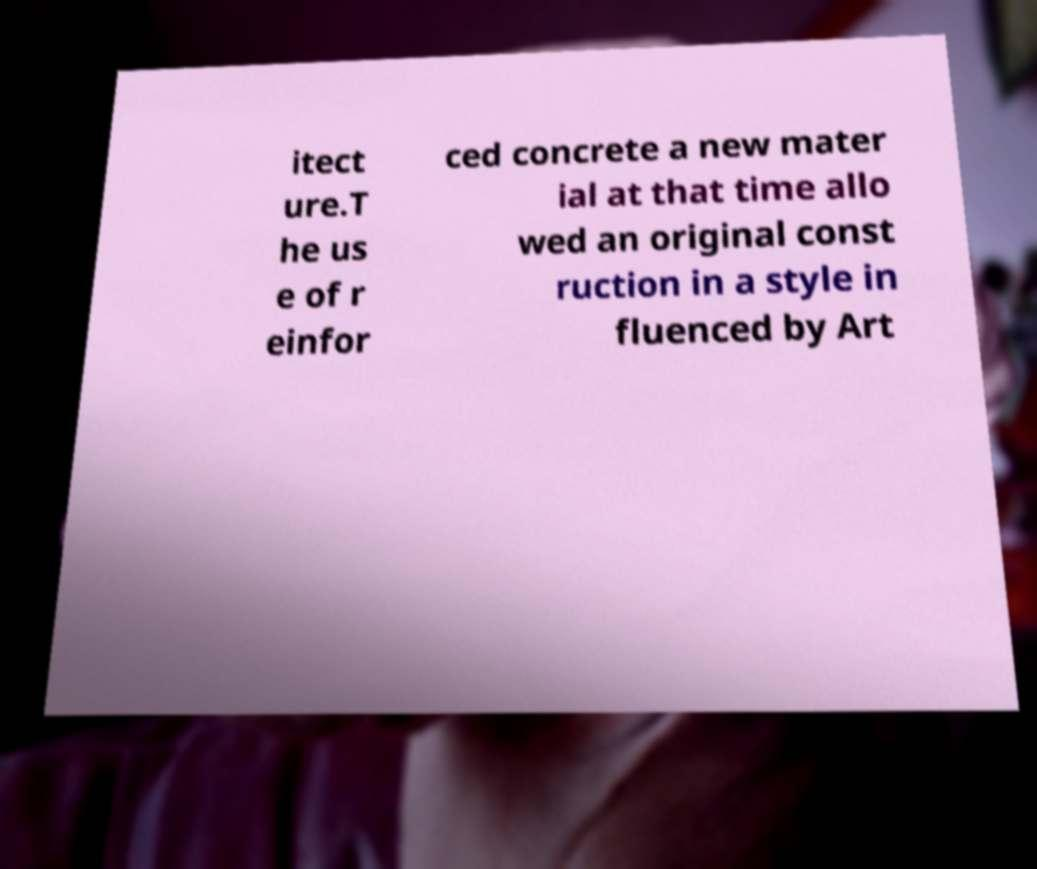I need the written content from this picture converted into text. Can you do that? itect ure.T he us e of r einfor ced concrete a new mater ial at that time allo wed an original const ruction in a style in fluenced by Art 